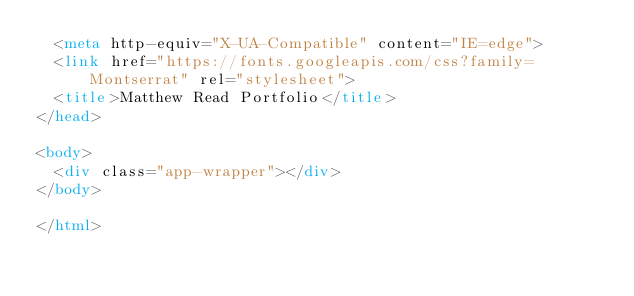Convert code to text. <code><loc_0><loc_0><loc_500><loc_500><_HTML_>  <meta http-equiv="X-UA-Compatible" content="IE=edge">
  <link href="https://fonts.googleapis.com/css?family=Montserrat" rel="stylesheet">
  <title>Matthew Read Portfolio</title>
</head>

<body>
  <div class="app-wrapper"></div>
</body>

</html></code> 